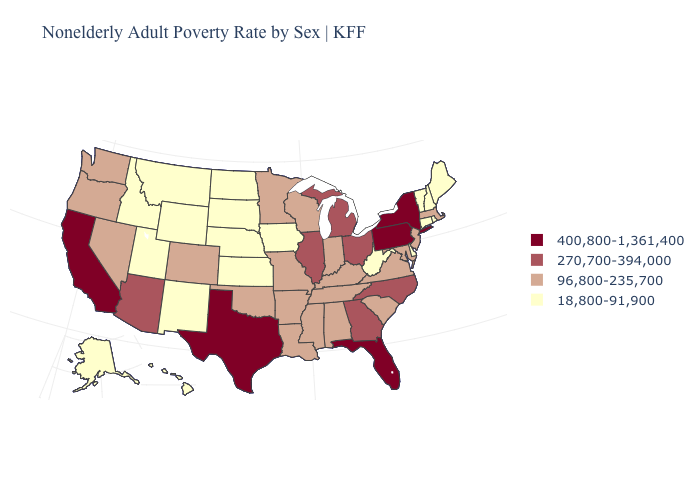What is the lowest value in the West?
Answer briefly. 18,800-91,900. What is the value of Idaho?
Quick response, please. 18,800-91,900. Does the first symbol in the legend represent the smallest category?
Short answer required. No. Does Maine have the lowest value in the Northeast?
Keep it brief. Yes. Name the states that have a value in the range 96,800-235,700?
Give a very brief answer. Alabama, Arkansas, Colorado, Indiana, Kentucky, Louisiana, Maryland, Massachusetts, Minnesota, Mississippi, Missouri, Nevada, New Jersey, Oklahoma, Oregon, South Carolina, Tennessee, Virginia, Washington, Wisconsin. What is the value of Alabama?
Concise answer only. 96,800-235,700. What is the lowest value in the USA?
Give a very brief answer. 18,800-91,900. Which states have the lowest value in the West?
Keep it brief. Alaska, Hawaii, Idaho, Montana, New Mexico, Utah, Wyoming. What is the lowest value in the West?
Write a very short answer. 18,800-91,900. Does New Hampshire have the lowest value in the USA?
Write a very short answer. Yes. What is the lowest value in the USA?
Be succinct. 18,800-91,900. Which states have the highest value in the USA?
Short answer required. California, Florida, New York, Pennsylvania, Texas. Which states hav the highest value in the South?
Be succinct. Florida, Texas. What is the value of Delaware?
Give a very brief answer. 18,800-91,900. Name the states that have a value in the range 270,700-394,000?
Keep it brief. Arizona, Georgia, Illinois, Michigan, North Carolina, Ohio. 